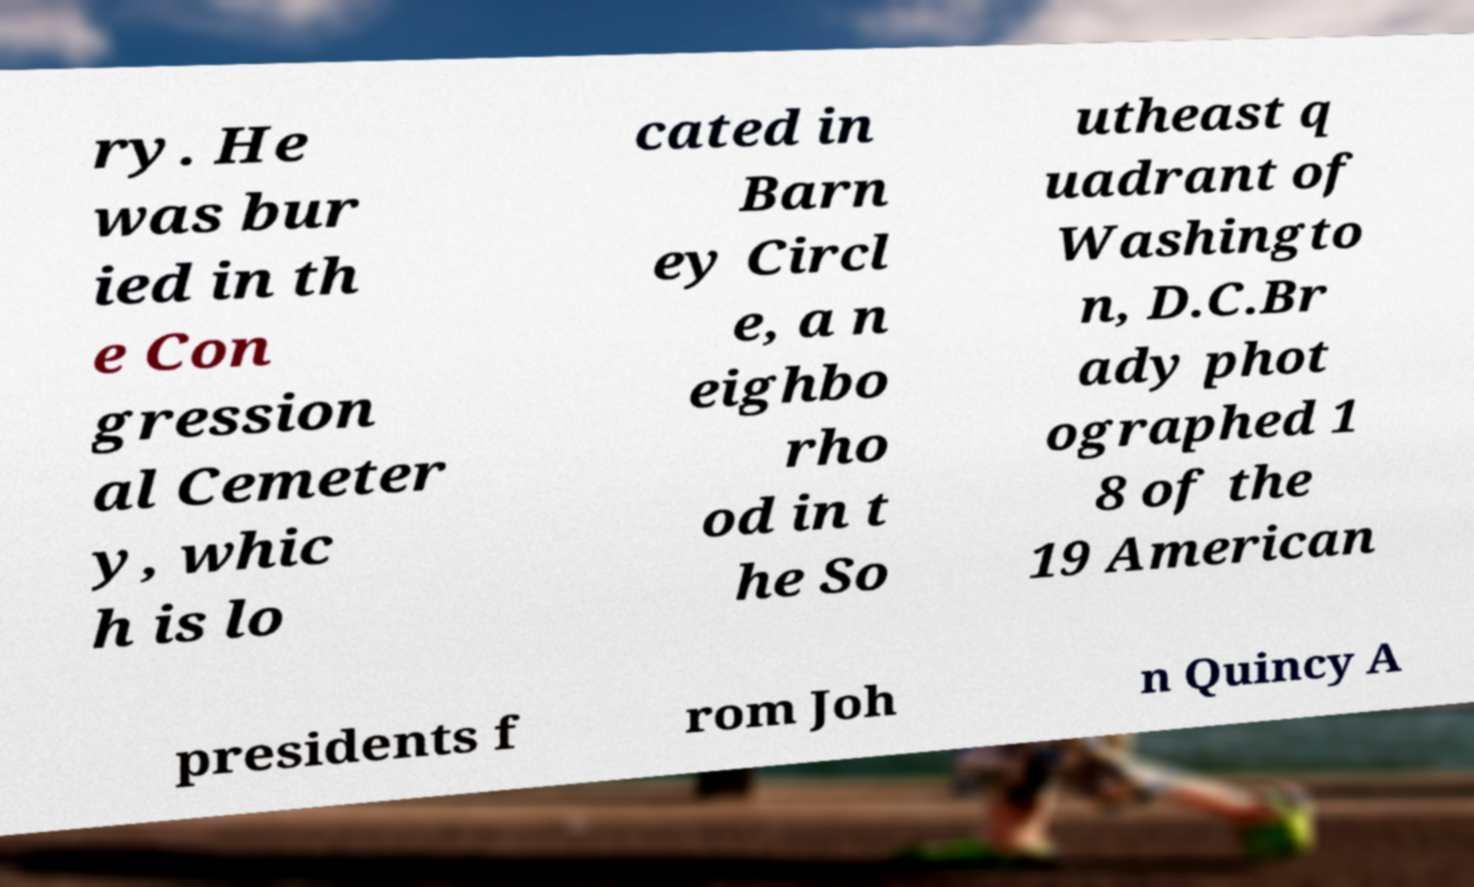I need the written content from this picture converted into text. Can you do that? ry. He was bur ied in th e Con gression al Cemeter y, whic h is lo cated in Barn ey Circl e, a n eighbo rho od in t he So utheast q uadrant of Washingto n, D.C.Br ady phot ographed 1 8 of the 19 American presidents f rom Joh n Quincy A 